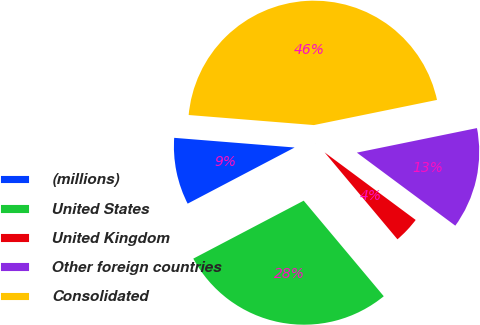<chart> <loc_0><loc_0><loc_500><loc_500><pie_chart><fcel>(millions)<fcel>United States<fcel>United Kingdom<fcel>Other foreign countries<fcel>Consolidated<nl><fcel>8.97%<fcel>28.41%<fcel>3.74%<fcel>13.37%<fcel>45.52%<nl></chart> 